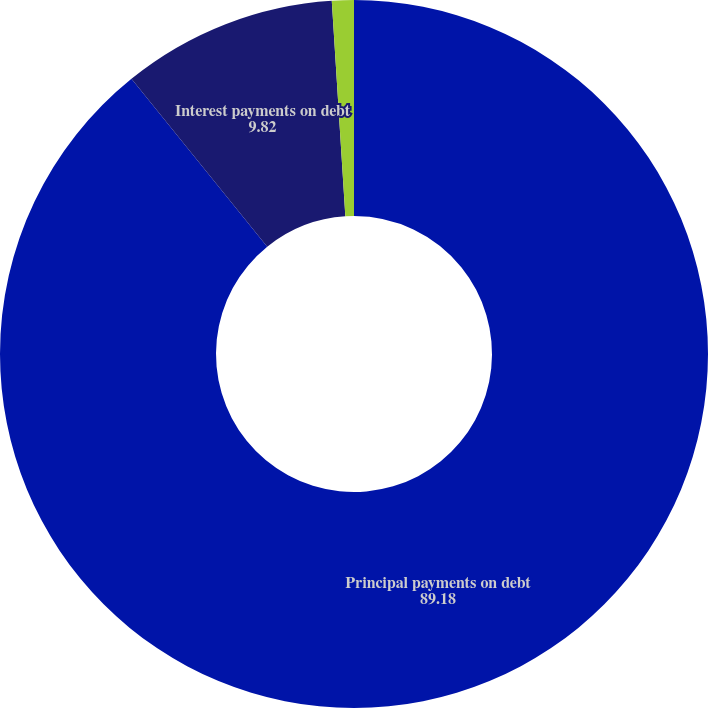Convert chart to OTSL. <chart><loc_0><loc_0><loc_500><loc_500><pie_chart><fcel>Principal payments on debt<fcel>Interest payments on debt<fcel>Operating lease payments<nl><fcel>89.18%<fcel>9.82%<fcel>1.0%<nl></chart> 